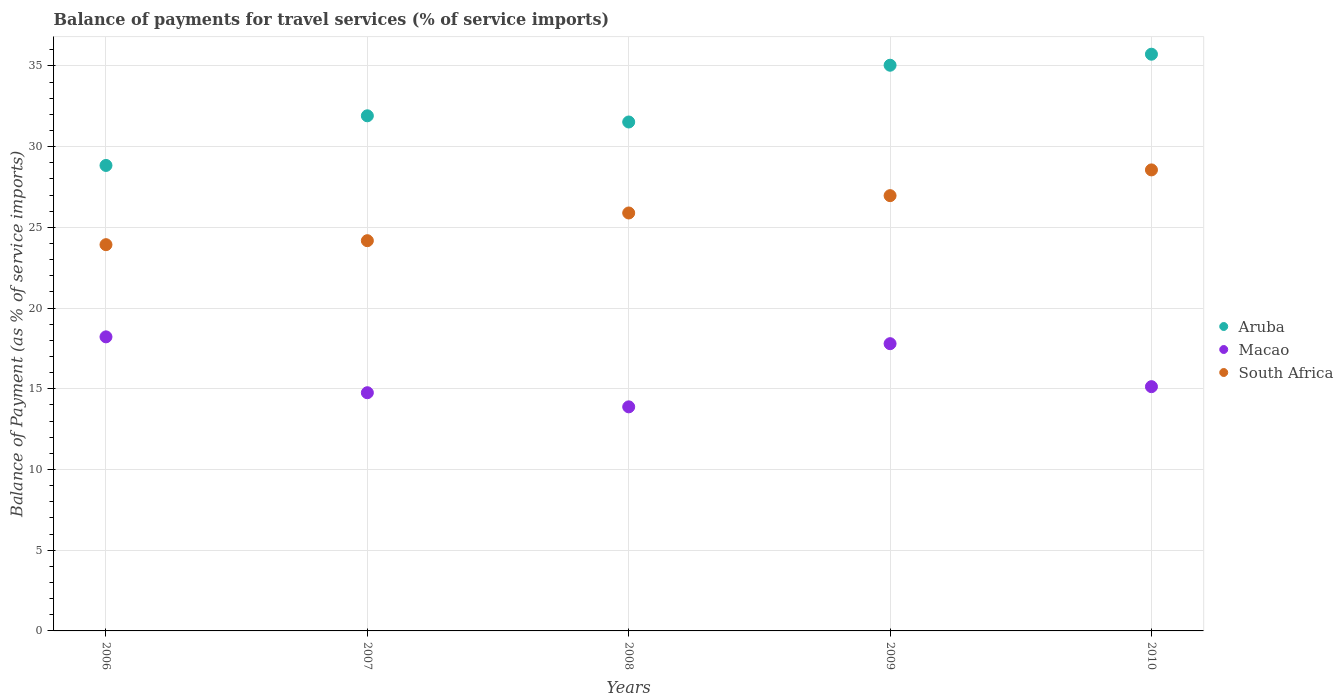How many different coloured dotlines are there?
Give a very brief answer. 3. What is the balance of payments for travel services in Macao in 2007?
Your answer should be very brief. 14.75. Across all years, what is the maximum balance of payments for travel services in Aruba?
Give a very brief answer. 35.72. Across all years, what is the minimum balance of payments for travel services in South Africa?
Provide a succinct answer. 23.93. In which year was the balance of payments for travel services in Aruba maximum?
Provide a succinct answer. 2010. What is the total balance of payments for travel services in South Africa in the graph?
Keep it short and to the point. 129.51. What is the difference between the balance of payments for travel services in Macao in 2008 and that in 2010?
Offer a very short reply. -1.25. What is the difference between the balance of payments for travel services in Macao in 2010 and the balance of payments for travel services in South Africa in 2009?
Your answer should be very brief. -11.83. What is the average balance of payments for travel services in South Africa per year?
Provide a succinct answer. 25.9. In the year 2009, what is the difference between the balance of payments for travel services in South Africa and balance of payments for travel services in Macao?
Provide a short and direct response. 9.17. What is the ratio of the balance of payments for travel services in South Africa in 2009 to that in 2010?
Offer a terse response. 0.94. Is the balance of payments for travel services in Aruba in 2007 less than that in 2010?
Your answer should be very brief. Yes. What is the difference between the highest and the second highest balance of payments for travel services in Aruba?
Provide a succinct answer. 0.68. What is the difference between the highest and the lowest balance of payments for travel services in Aruba?
Keep it short and to the point. 6.89. In how many years, is the balance of payments for travel services in Aruba greater than the average balance of payments for travel services in Aruba taken over all years?
Your response must be concise. 2. Is the sum of the balance of payments for travel services in Aruba in 2007 and 2010 greater than the maximum balance of payments for travel services in South Africa across all years?
Keep it short and to the point. Yes. Is it the case that in every year, the sum of the balance of payments for travel services in Aruba and balance of payments for travel services in South Africa  is greater than the balance of payments for travel services in Macao?
Your answer should be compact. Yes. Is the balance of payments for travel services in Aruba strictly less than the balance of payments for travel services in South Africa over the years?
Your answer should be very brief. No. How many dotlines are there?
Make the answer very short. 3. How many years are there in the graph?
Ensure brevity in your answer.  5. What is the difference between two consecutive major ticks on the Y-axis?
Give a very brief answer. 5. Are the values on the major ticks of Y-axis written in scientific E-notation?
Your response must be concise. No. Does the graph contain any zero values?
Keep it short and to the point. No. Does the graph contain grids?
Provide a succinct answer. Yes. How many legend labels are there?
Your answer should be very brief. 3. How are the legend labels stacked?
Offer a terse response. Vertical. What is the title of the graph?
Provide a succinct answer. Balance of payments for travel services (% of service imports). Does "Burkina Faso" appear as one of the legend labels in the graph?
Your response must be concise. No. What is the label or title of the Y-axis?
Make the answer very short. Balance of Payment (as % of service imports). What is the Balance of Payment (as % of service imports) in Aruba in 2006?
Keep it short and to the point. 28.83. What is the Balance of Payment (as % of service imports) of Macao in 2006?
Make the answer very short. 18.22. What is the Balance of Payment (as % of service imports) in South Africa in 2006?
Give a very brief answer. 23.93. What is the Balance of Payment (as % of service imports) of Aruba in 2007?
Offer a terse response. 31.91. What is the Balance of Payment (as % of service imports) of Macao in 2007?
Your response must be concise. 14.75. What is the Balance of Payment (as % of service imports) of South Africa in 2007?
Keep it short and to the point. 24.17. What is the Balance of Payment (as % of service imports) of Aruba in 2008?
Give a very brief answer. 31.52. What is the Balance of Payment (as % of service imports) of Macao in 2008?
Give a very brief answer. 13.88. What is the Balance of Payment (as % of service imports) of South Africa in 2008?
Your answer should be very brief. 25.89. What is the Balance of Payment (as % of service imports) in Aruba in 2009?
Give a very brief answer. 35.04. What is the Balance of Payment (as % of service imports) of Macao in 2009?
Give a very brief answer. 17.79. What is the Balance of Payment (as % of service imports) in South Africa in 2009?
Give a very brief answer. 26.96. What is the Balance of Payment (as % of service imports) of Aruba in 2010?
Provide a succinct answer. 35.72. What is the Balance of Payment (as % of service imports) of Macao in 2010?
Give a very brief answer. 15.13. What is the Balance of Payment (as % of service imports) of South Africa in 2010?
Keep it short and to the point. 28.56. Across all years, what is the maximum Balance of Payment (as % of service imports) in Aruba?
Ensure brevity in your answer.  35.72. Across all years, what is the maximum Balance of Payment (as % of service imports) in Macao?
Give a very brief answer. 18.22. Across all years, what is the maximum Balance of Payment (as % of service imports) in South Africa?
Offer a terse response. 28.56. Across all years, what is the minimum Balance of Payment (as % of service imports) in Aruba?
Your answer should be compact. 28.83. Across all years, what is the minimum Balance of Payment (as % of service imports) of Macao?
Give a very brief answer. 13.88. Across all years, what is the minimum Balance of Payment (as % of service imports) in South Africa?
Keep it short and to the point. 23.93. What is the total Balance of Payment (as % of service imports) in Aruba in the graph?
Provide a succinct answer. 163.03. What is the total Balance of Payment (as % of service imports) in Macao in the graph?
Offer a terse response. 79.77. What is the total Balance of Payment (as % of service imports) of South Africa in the graph?
Offer a very short reply. 129.51. What is the difference between the Balance of Payment (as % of service imports) in Aruba in 2006 and that in 2007?
Your answer should be very brief. -3.08. What is the difference between the Balance of Payment (as % of service imports) in Macao in 2006 and that in 2007?
Give a very brief answer. 3.46. What is the difference between the Balance of Payment (as % of service imports) of South Africa in 2006 and that in 2007?
Keep it short and to the point. -0.25. What is the difference between the Balance of Payment (as % of service imports) in Aruba in 2006 and that in 2008?
Offer a very short reply. -2.69. What is the difference between the Balance of Payment (as % of service imports) of Macao in 2006 and that in 2008?
Ensure brevity in your answer.  4.34. What is the difference between the Balance of Payment (as % of service imports) of South Africa in 2006 and that in 2008?
Keep it short and to the point. -1.96. What is the difference between the Balance of Payment (as % of service imports) of Aruba in 2006 and that in 2009?
Make the answer very short. -6.21. What is the difference between the Balance of Payment (as % of service imports) in Macao in 2006 and that in 2009?
Your answer should be very brief. 0.42. What is the difference between the Balance of Payment (as % of service imports) of South Africa in 2006 and that in 2009?
Make the answer very short. -3.04. What is the difference between the Balance of Payment (as % of service imports) in Aruba in 2006 and that in 2010?
Give a very brief answer. -6.89. What is the difference between the Balance of Payment (as % of service imports) of Macao in 2006 and that in 2010?
Provide a short and direct response. 3.09. What is the difference between the Balance of Payment (as % of service imports) of South Africa in 2006 and that in 2010?
Offer a very short reply. -4.63. What is the difference between the Balance of Payment (as % of service imports) in Aruba in 2007 and that in 2008?
Offer a terse response. 0.38. What is the difference between the Balance of Payment (as % of service imports) in Macao in 2007 and that in 2008?
Make the answer very short. 0.87. What is the difference between the Balance of Payment (as % of service imports) in South Africa in 2007 and that in 2008?
Keep it short and to the point. -1.72. What is the difference between the Balance of Payment (as % of service imports) in Aruba in 2007 and that in 2009?
Provide a succinct answer. -3.13. What is the difference between the Balance of Payment (as % of service imports) of Macao in 2007 and that in 2009?
Your answer should be compact. -3.04. What is the difference between the Balance of Payment (as % of service imports) of South Africa in 2007 and that in 2009?
Your response must be concise. -2.79. What is the difference between the Balance of Payment (as % of service imports) of Aruba in 2007 and that in 2010?
Make the answer very short. -3.82. What is the difference between the Balance of Payment (as % of service imports) in Macao in 2007 and that in 2010?
Provide a succinct answer. -0.38. What is the difference between the Balance of Payment (as % of service imports) in South Africa in 2007 and that in 2010?
Your answer should be very brief. -4.38. What is the difference between the Balance of Payment (as % of service imports) in Aruba in 2008 and that in 2009?
Ensure brevity in your answer.  -3.52. What is the difference between the Balance of Payment (as % of service imports) in Macao in 2008 and that in 2009?
Provide a succinct answer. -3.91. What is the difference between the Balance of Payment (as % of service imports) in South Africa in 2008 and that in 2009?
Keep it short and to the point. -1.07. What is the difference between the Balance of Payment (as % of service imports) in Aruba in 2008 and that in 2010?
Give a very brief answer. -4.2. What is the difference between the Balance of Payment (as % of service imports) in Macao in 2008 and that in 2010?
Your answer should be very brief. -1.25. What is the difference between the Balance of Payment (as % of service imports) of South Africa in 2008 and that in 2010?
Your answer should be compact. -2.67. What is the difference between the Balance of Payment (as % of service imports) of Aruba in 2009 and that in 2010?
Provide a short and direct response. -0.68. What is the difference between the Balance of Payment (as % of service imports) in Macao in 2009 and that in 2010?
Offer a terse response. 2.66. What is the difference between the Balance of Payment (as % of service imports) in South Africa in 2009 and that in 2010?
Keep it short and to the point. -1.59. What is the difference between the Balance of Payment (as % of service imports) of Aruba in 2006 and the Balance of Payment (as % of service imports) of Macao in 2007?
Provide a succinct answer. 14.08. What is the difference between the Balance of Payment (as % of service imports) of Aruba in 2006 and the Balance of Payment (as % of service imports) of South Africa in 2007?
Offer a terse response. 4.66. What is the difference between the Balance of Payment (as % of service imports) in Macao in 2006 and the Balance of Payment (as % of service imports) in South Africa in 2007?
Ensure brevity in your answer.  -5.96. What is the difference between the Balance of Payment (as % of service imports) of Aruba in 2006 and the Balance of Payment (as % of service imports) of Macao in 2008?
Give a very brief answer. 14.95. What is the difference between the Balance of Payment (as % of service imports) in Aruba in 2006 and the Balance of Payment (as % of service imports) in South Africa in 2008?
Offer a very short reply. 2.94. What is the difference between the Balance of Payment (as % of service imports) of Macao in 2006 and the Balance of Payment (as % of service imports) of South Africa in 2008?
Your response must be concise. -7.67. What is the difference between the Balance of Payment (as % of service imports) of Aruba in 2006 and the Balance of Payment (as % of service imports) of Macao in 2009?
Your answer should be compact. 11.04. What is the difference between the Balance of Payment (as % of service imports) in Aruba in 2006 and the Balance of Payment (as % of service imports) in South Africa in 2009?
Provide a short and direct response. 1.87. What is the difference between the Balance of Payment (as % of service imports) in Macao in 2006 and the Balance of Payment (as % of service imports) in South Africa in 2009?
Provide a succinct answer. -8.75. What is the difference between the Balance of Payment (as % of service imports) in Aruba in 2006 and the Balance of Payment (as % of service imports) in Macao in 2010?
Ensure brevity in your answer.  13.7. What is the difference between the Balance of Payment (as % of service imports) of Aruba in 2006 and the Balance of Payment (as % of service imports) of South Africa in 2010?
Provide a succinct answer. 0.28. What is the difference between the Balance of Payment (as % of service imports) of Macao in 2006 and the Balance of Payment (as % of service imports) of South Africa in 2010?
Provide a short and direct response. -10.34. What is the difference between the Balance of Payment (as % of service imports) of Aruba in 2007 and the Balance of Payment (as % of service imports) of Macao in 2008?
Provide a succinct answer. 18.03. What is the difference between the Balance of Payment (as % of service imports) in Aruba in 2007 and the Balance of Payment (as % of service imports) in South Africa in 2008?
Ensure brevity in your answer.  6.02. What is the difference between the Balance of Payment (as % of service imports) in Macao in 2007 and the Balance of Payment (as % of service imports) in South Africa in 2008?
Keep it short and to the point. -11.13. What is the difference between the Balance of Payment (as % of service imports) of Aruba in 2007 and the Balance of Payment (as % of service imports) of Macao in 2009?
Give a very brief answer. 14.12. What is the difference between the Balance of Payment (as % of service imports) of Aruba in 2007 and the Balance of Payment (as % of service imports) of South Africa in 2009?
Your answer should be compact. 4.95. What is the difference between the Balance of Payment (as % of service imports) of Macao in 2007 and the Balance of Payment (as % of service imports) of South Africa in 2009?
Provide a succinct answer. -12.21. What is the difference between the Balance of Payment (as % of service imports) in Aruba in 2007 and the Balance of Payment (as % of service imports) in Macao in 2010?
Provide a short and direct response. 16.78. What is the difference between the Balance of Payment (as % of service imports) in Aruba in 2007 and the Balance of Payment (as % of service imports) in South Africa in 2010?
Give a very brief answer. 3.35. What is the difference between the Balance of Payment (as % of service imports) of Macao in 2007 and the Balance of Payment (as % of service imports) of South Africa in 2010?
Make the answer very short. -13.8. What is the difference between the Balance of Payment (as % of service imports) of Aruba in 2008 and the Balance of Payment (as % of service imports) of Macao in 2009?
Your answer should be compact. 13.73. What is the difference between the Balance of Payment (as % of service imports) of Aruba in 2008 and the Balance of Payment (as % of service imports) of South Africa in 2009?
Make the answer very short. 4.56. What is the difference between the Balance of Payment (as % of service imports) of Macao in 2008 and the Balance of Payment (as % of service imports) of South Africa in 2009?
Offer a terse response. -13.08. What is the difference between the Balance of Payment (as % of service imports) of Aruba in 2008 and the Balance of Payment (as % of service imports) of Macao in 2010?
Offer a very short reply. 16.39. What is the difference between the Balance of Payment (as % of service imports) of Aruba in 2008 and the Balance of Payment (as % of service imports) of South Africa in 2010?
Your answer should be very brief. 2.97. What is the difference between the Balance of Payment (as % of service imports) in Macao in 2008 and the Balance of Payment (as % of service imports) in South Africa in 2010?
Keep it short and to the point. -14.68. What is the difference between the Balance of Payment (as % of service imports) in Aruba in 2009 and the Balance of Payment (as % of service imports) in Macao in 2010?
Ensure brevity in your answer.  19.91. What is the difference between the Balance of Payment (as % of service imports) in Aruba in 2009 and the Balance of Payment (as % of service imports) in South Africa in 2010?
Ensure brevity in your answer.  6.48. What is the difference between the Balance of Payment (as % of service imports) in Macao in 2009 and the Balance of Payment (as % of service imports) in South Africa in 2010?
Provide a succinct answer. -10.76. What is the average Balance of Payment (as % of service imports) of Aruba per year?
Provide a succinct answer. 32.61. What is the average Balance of Payment (as % of service imports) in Macao per year?
Keep it short and to the point. 15.95. What is the average Balance of Payment (as % of service imports) of South Africa per year?
Give a very brief answer. 25.9. In the year 2006, what is the difference between the Balance of Payment (as % of service imports) in Aruba and Balance of Payment (as % of service imports) in Macao?
Offer a terse response. 10.62. In the year 2006, what is the difference between the Balance of Payment (as % of service imports) in Aruba and Balance of Payment (as % of service imports) in South Africa?
Provide a succinct answer. 4.91. In the year 2006, what is the difference between the Balance of Payment (as % of service imports) of Macao and Balance of Payment (as % of service imports) of South Africa?
Keep it short and to the point. -5.71. In the year 2007, what is the difference between the Balance of Payment (as % of service imports) of Aruba and Balance of Payment (as % of service imports) of Macao?
Make the answer very short. 17.15. In the year 2007, what is the difference between the Balance of Payment (as % of service imports) in Aruba and Balance of Payment (as % of service imports) in South Africa?
Offer a very short reply. 7.74. In the year 2007, what is the difference between the Balance of Payment (as % of service imports) in Macao and Balance of Payment (as % of service imports) in South Africa?
Give a very brief answer. -9.42. In the year 2008, what is the difference between the Balance of Payment (as % of service imports) of Aruba and Balance of Payment (as % of service imports) of Macao?
Ensure brevity in your answer.  17.65. In the year 2008, what is the difference between the Balance of Payment (as % of service imports) of Aruba and Balance of Payment (as % of service imports) of South Africa?
Provide a succinct answer. 5.64. In the year 2008, what is the difference between the Balance of Payment (as % of service imports) of Macao and Balance of Payment (as % of service imports) of South Africa?
Your response must be concise. -12.01. In the year 2009, what is the difference between the Balance of Payment (as % of service imports) in Aruba and Balance of Payment (as % of service imports) in Macao?
Offer a terse response. 17.25. In the year 2009, what is the difference between the Balance of Payment (as % of service imports) of Aruba and Balance of Payment (as % of service imports) of South Africa?
Give a very brief answer. 8.08. In the year 2009, what is the difference between the Balance of Payment (as % of service imports) of Macao and Balance of Payment (as % of service imports) of South Africa?
Offer a terse response. -9.17. In the year 2010, what is the difference between the Balance of Payment (as % of service imports) in Aruba and Balance of Payment (as % of service imports) in Macao?
Your answer should be compact. 20.59. In the year 2010, what is the difference between the Balance of Payment (as % of service imports) of Aruba and Balance of Payment (as % of service imports) of South Africa?
Give a very brief answer. 7.17. In the year 2010, what is the difference between the Balance of Payment (as % of service imports) in Macao and Balance of Payment (as % of service imports) in South Africa?
Your answer should be compact. -13.43. What is the ratio of the Balance of Payment (as % of service imports) of Aruba in 2006 to that in 2007?
Your answer should be compact. 0.9. What is the ratio of the Balance of Payment (as % of service imports) in Macao in 2006 to that in 2007?
Offer a terse response. 1.23. What is the ratio of the Balance of Payment (as % of service imports) in South Africa in 2006 to that in 2007?
Ensure brevity in your answer.  0.99. What is the ratio of the Balance of Payment (as % of service imports) of Aruba in 2006 to that in 2008?
Give a very brief answer. 0.91. What is the ratio of the Balance of Payment (as % of service imports) in Macao in 2006 to that in 2008?
Provide a succinct answer. 1.31. What is the ratio of the Balance of Payment (as % of service imports) of South Africa in 2006 to that in 2008?
Offer a very short reply. 0.92. What is the ratio of the Balance of Payment (as % of service imports) of Aruba in 2006 to that in 2009?
Your answer should be compact. 0.82. What is the ratio of the Balance of Payment (as % of service imports) in Macao in 2006 to that in 2009?
Your answer should be compact. 1.02. What is the ratio of the Balance of Payment (as % of service imports) in South Africa in 2006 to that in 2009?
Provide a succinct answer. 0.89. What is the ratio of the Balance of Payment (as % of service imports) of Aruba in 2006 to that in 2010?
Give a very brief answer. 0.81. What is the ratio of the Balance of Payment (as % of service imports) of Macao in 2006 to that in 2010?
Your answer should be compact. 1.2. What is the ratio of the Balance of Payment (as % of service imports) of South Africa in 2006 to that in 2010?
Provide a succinct answer. 0.84. What is the ratio of the Balance of Payment (as % of service imports) in Aruba in 2007 to that in 2008?
Offer a terse response. 1.01. What is the ratio of the Balance of Payment (as % of service imports) of Macao in 2007 to that in 2008?
Offer a very short reply. 1.06. What is the ratio of the Balance of Payment (as % of service imports) in South Africa in 2007 to that in 2008?
Make the answer very short. 0.93. What is the ratio of the Balance of Payment (as % of service imports) of Aruba in 2007 to that in 2009?
Offer a terse response. 0.91. What is the ratio of the Balance of Payment (as % of service imports) in Macao in 2007 to that in 2009?
Provide a succinct answer. 0.83. What is the ratio of the Balance of Payment (as % of service imports) in South Africa in 2007 to that in 2009?
Your answer should be compact. 0.9. What is the ratio of the Balance of Payment (as % of service imports) in Aruba in 2007 to that in 2010?
Your answer should be very brief. 0.89. What is the ratio of the Balance of Payment (as % of service imports) of Macao in 2007 to that in 2010?
Offer a very short reply. 0.98. What is the ratio of the Balance of Payment (as % of service imports) of South Africa in 2007 to that in 2010?
Provide a short and direct response. 0.85. What is the ratio of the Balance of Payment (as % of service imports) of Aruba in 2008 to that in 2009?
Offer a very short reply. 0.9. What is the ratio of the Balance of Payment (as % of service imports) in Macao in 2008 to that in 2009?
Offer a very short reply. 0.78. What is the ratio of the Balance of Payment (as % of service imports) of South Africa in 2008 to that in 2009?
Ensure brevity in your answer.  0.96. What is the ratio of the Balance of Payment (as % of service imports) in Aruba in 2008 to that in 2010?
Keep it short and to the point. 0.88. What is the ratio of the Balance of Payment (as % of service imports) in Macao in 2008 to that in 2010?
Offer a terse response. 0.92. What is the ratio of the Balance of Payment (as % of service imports) of South Africa in 2008 to that in 2010?
Keep it short and to the point. 0.91. What is the ratio of the Balance of Payment (as % of service imports) of Aruba in 2009 to that in 2010?
Offer a very short reply. 0.98. What is the ratio of the Balance of Payment (as % of service imports) of Macao in 2009 to that in 2010?
Your answer should be very brief. 1.18. What is the ratio of the Balance of Payment (as % of service imports) of South Africa in 2009 to that in 2010?
Provide a succinct answer. 0.94. What is the difference between the highest and the second highest Balance of Payment (as % of service imports) of Aruba?
Give a very brief answer. 0.68. What is the difference between the highest and the second highest Balance of Payment (as % of service imports) in Macao?
Provide a short and direct response. 0.42. What is the difference between the highest and the second highest Balance of Payment (as % of service imports) of South Africa?
Make the answer very short. 1.59. What is the difference between the highest and the lowest Balance of Payment (as % of service imports) in Aruba?
Offer a terse response. 6.89. What is the difference between the highest and the lowest Balance of Payment (as % of service imports) of Macao?
Your answer should be very brief. 4.34. What is the difference between the highest and the lowest Balance of Payment (as % of service imports) of South Africa?
Your response must be concise. 4.63. 